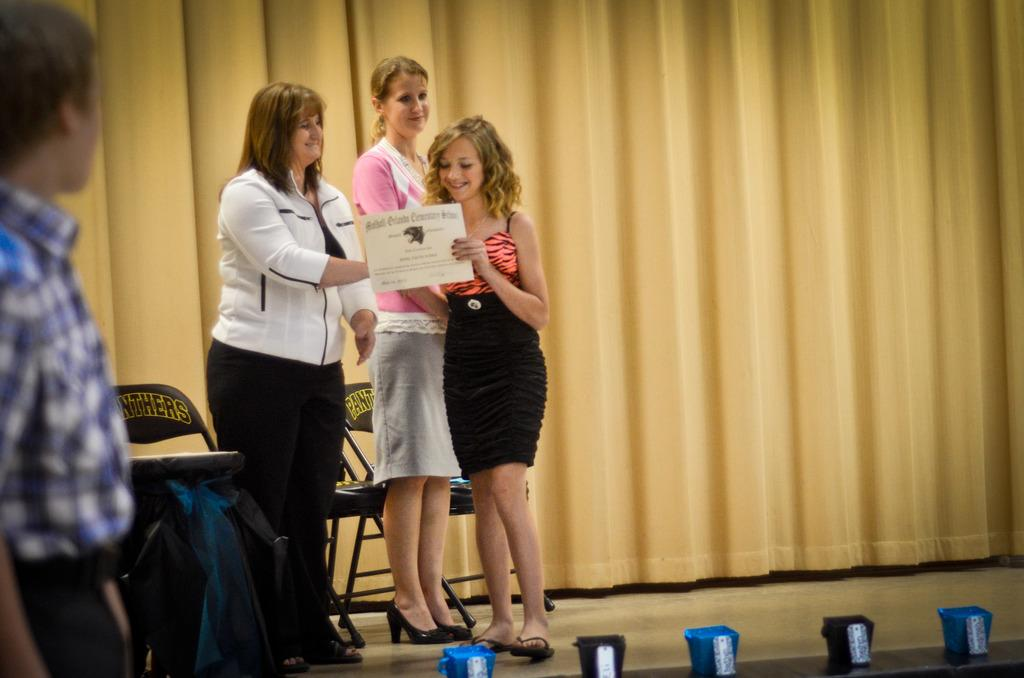Who is present in the image? There is a woman, two girls, and a man in the image. How many chairs are visible in the image? There are three chairs in the image. What can be seen hanging in the background of the image? There is a curtain in the image. Where is the man located in the image? The man is standing on the left side of the image. What type of jelly can be seen on the floor in the image? There is no jelly present on the floor in the image. Is there a hammer being used by any of the individuals in the image? There is no hammer visible in the image. 